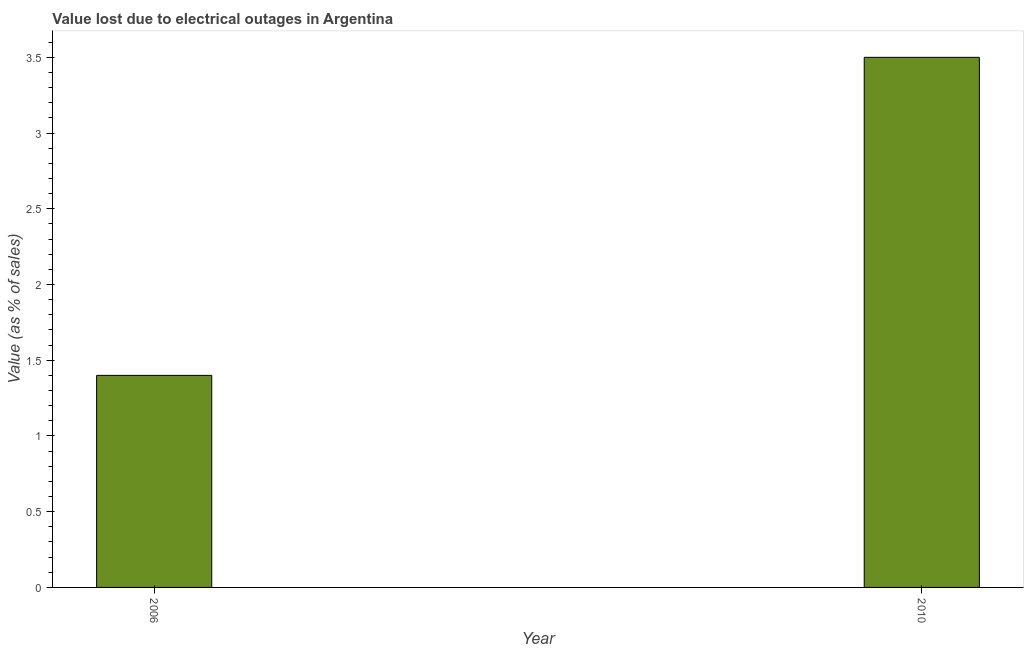Does the graph contain grids?
Keep it short and to the point. No. What is the title of the graph?
Give a very brief answer. Value lost due to electrical outages in Argentina. What is the label or title of the X-axis?
Your answer should be very brief. Year. What is the label or title of the Y-axis?
Your answer should be very brief. Value (as % of sales). In which year was the value lost due to electrical outages maximum?
Provide a succinct answer. 2010. What is the sum of the value lost due to electrical outages?
Offer a terse response. 4.9. What is the difference between the value lost due to electrical outages in 2006 and 2010?
Provide a succinct answer. -2.1. What is the average value lost due to electrical outages per year?
Offer a very short reply. 2.45. What is the median value lost due to electrical outages?
Offer a very short reply. 2.45. In how many years, is the value lost due to electrical outages greater than 1.9 %?
Ensure brevity in your answer.  1. Do a majority of the years between 2006 and 2010 (inclusive) have value lost due to electrical outages greater than 1.1 %?
Your answer should be compact. Yes. What is the ratio of the value lost due to electrical outages in 2006 to that in 2010?
Give a very brief answer. 0.4. Are all the bars in the graph horizontal?
Your answer should be very brief. No. What is the difference between two consecutive major ticks on the Y-axis?
Provide a short and direct response. 0.5. Are the values on the major ticks of Y-axis written in scientific E-notation?
Ensure brevity in your answer.  No. What is the Value (as % of sales) in 2010?
Ensure brevity in your answer.  3.5. 